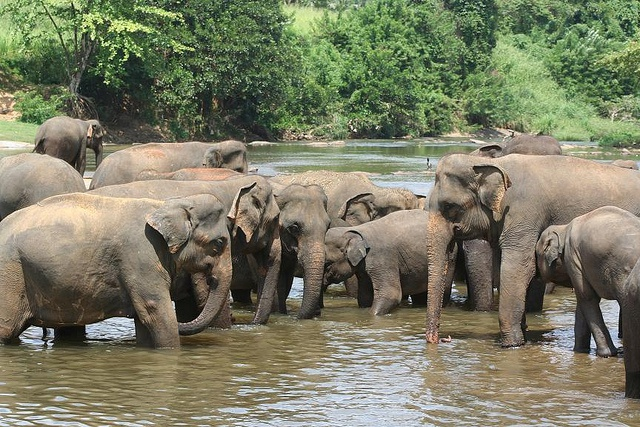Describe the objects in this image and their specific colors. I can see elephant in khaki, black, gray, and darkgray tones, elephant in khaki, darkgray, gray, and tan tones, elephant in khaki, black, darkgray, gray, and tan tones, elephant in khaki, gray, black, and darkgray tones, and elephant in khaki, black, tan, gray, and darkgray tones in this image. 